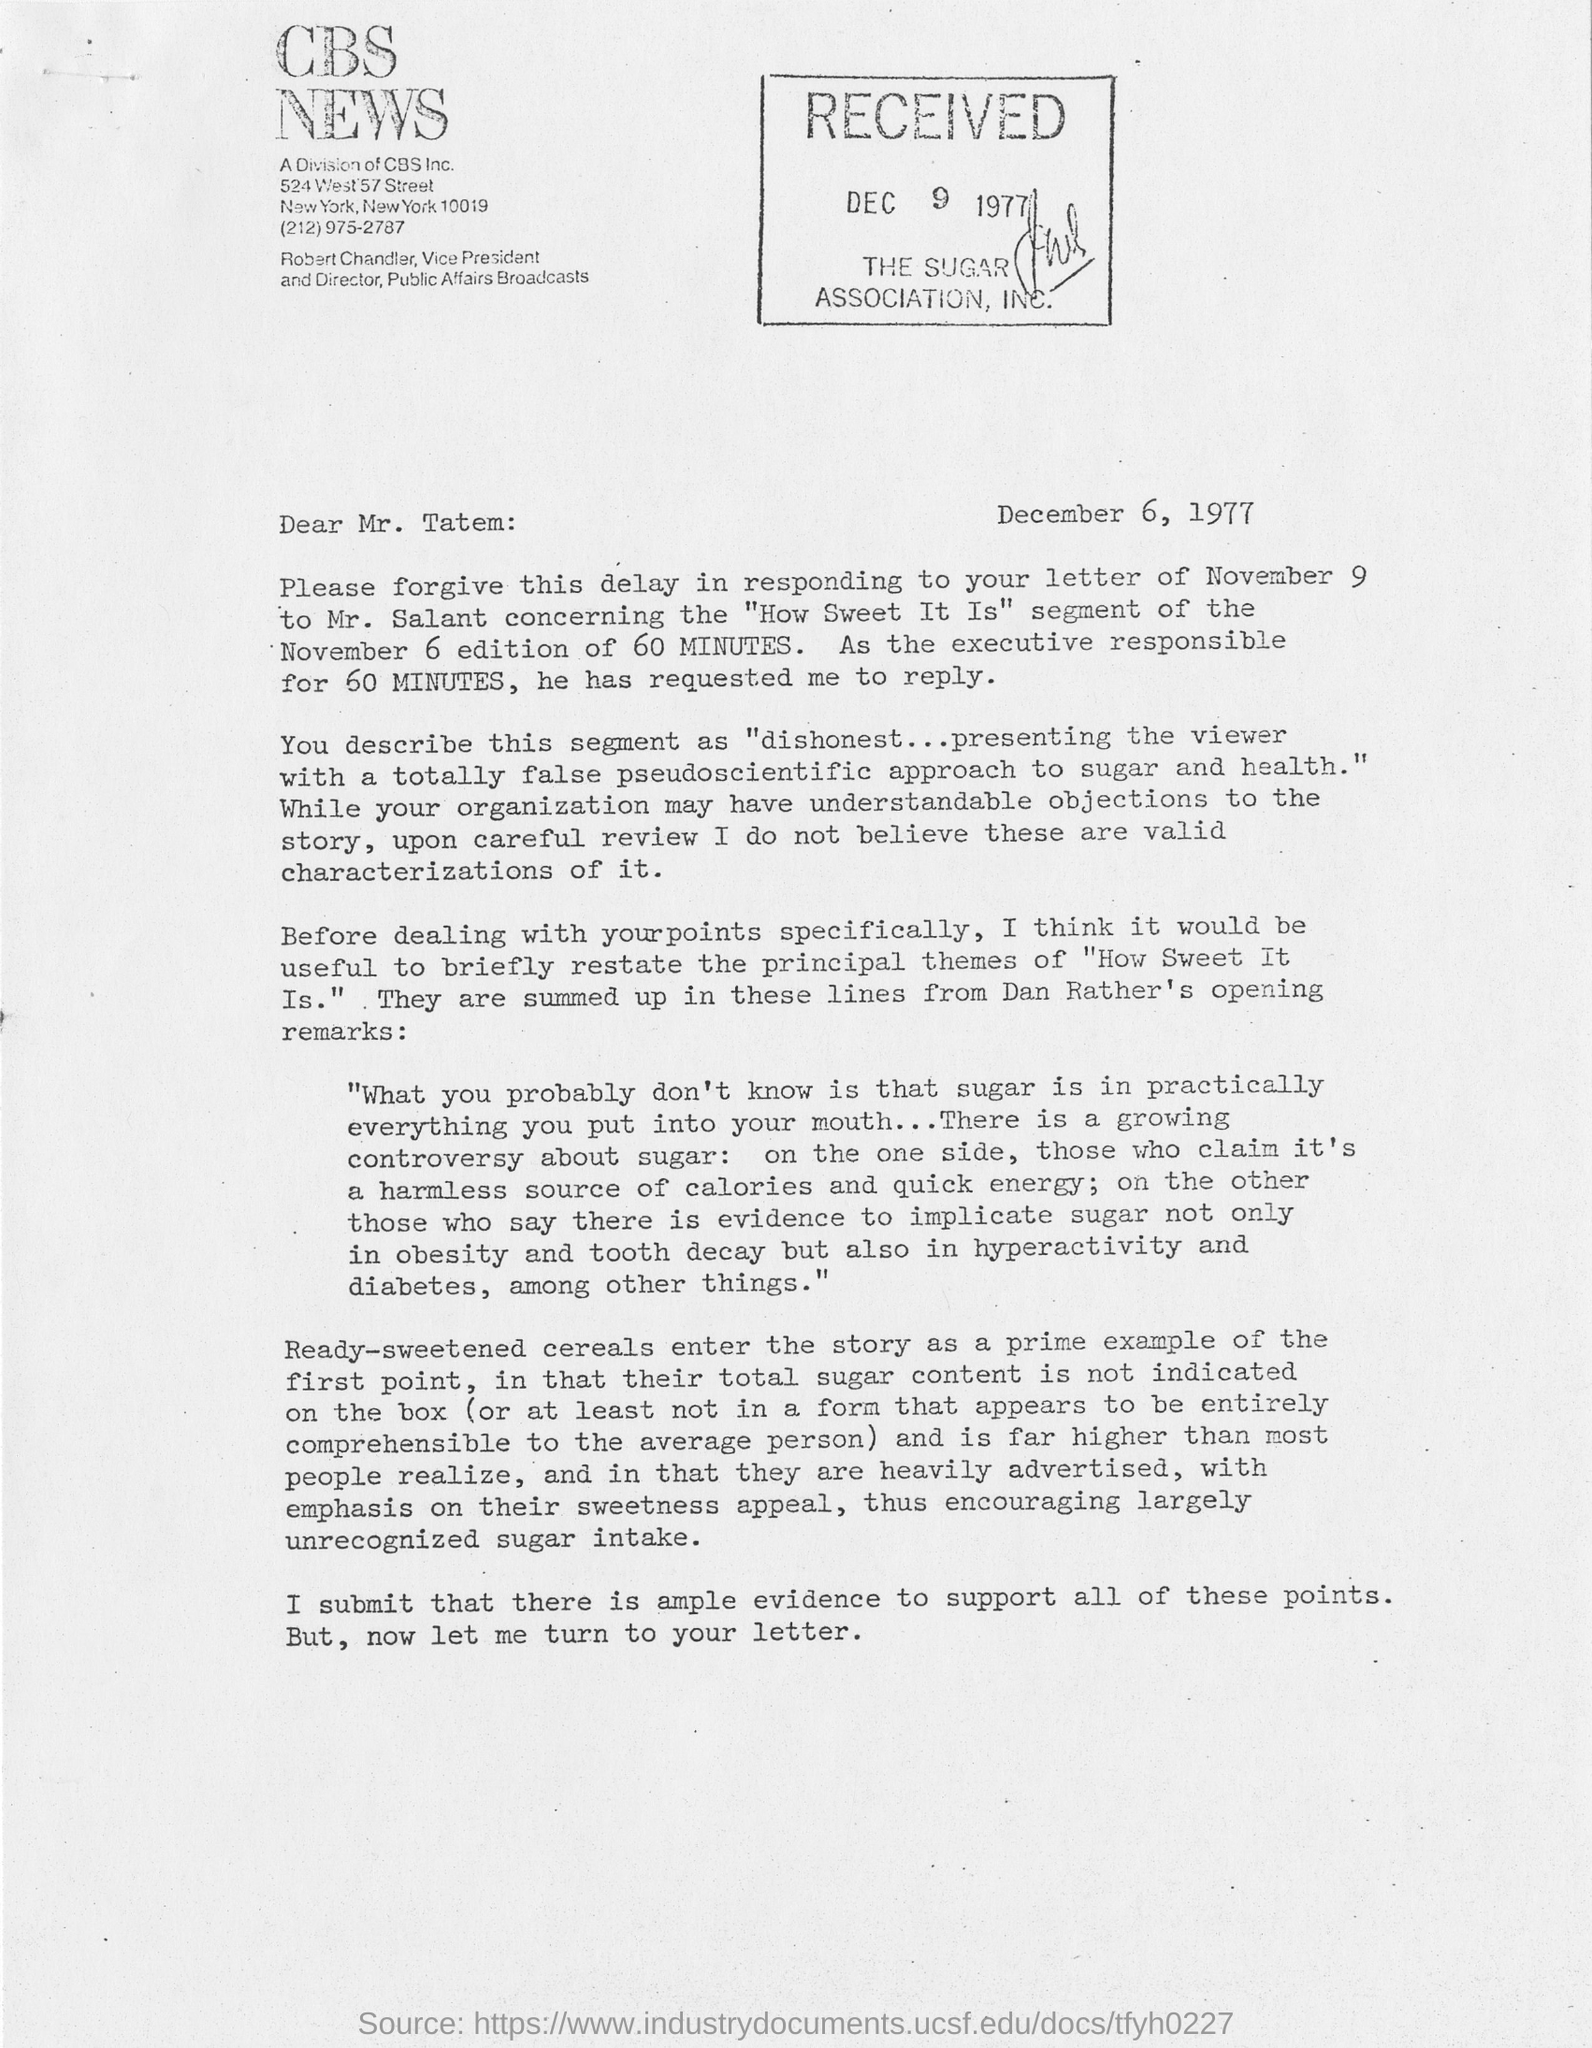What is date of this letter?
Your response must be concise. December 6, 1977. What is the name of company?
Ensure brevity in your answer.  CBS NEWS. To whom this letter is addressed?
Your response must be concise. MR. TATEM. What is the received date of this letter?
Provide a short and direct response. DEC 9 1977. 